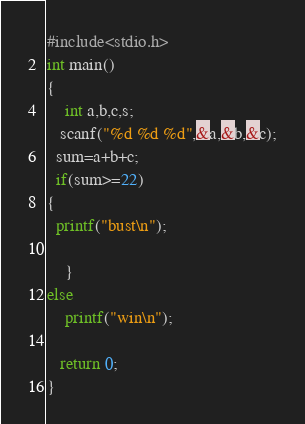<code> <loc_0><loc_0><loc_500><loc_500><_Awk_>#include<stdio.h>
int main()
{ 
    int a,b,c,s;
   scanf("%d %d %d",&a,&b,&c);
  sum=a+b+c;
  if(sum>=22)
{
  printf("bust\n");

    }
else
    printf("win\n");

   return 0;
}</code> 